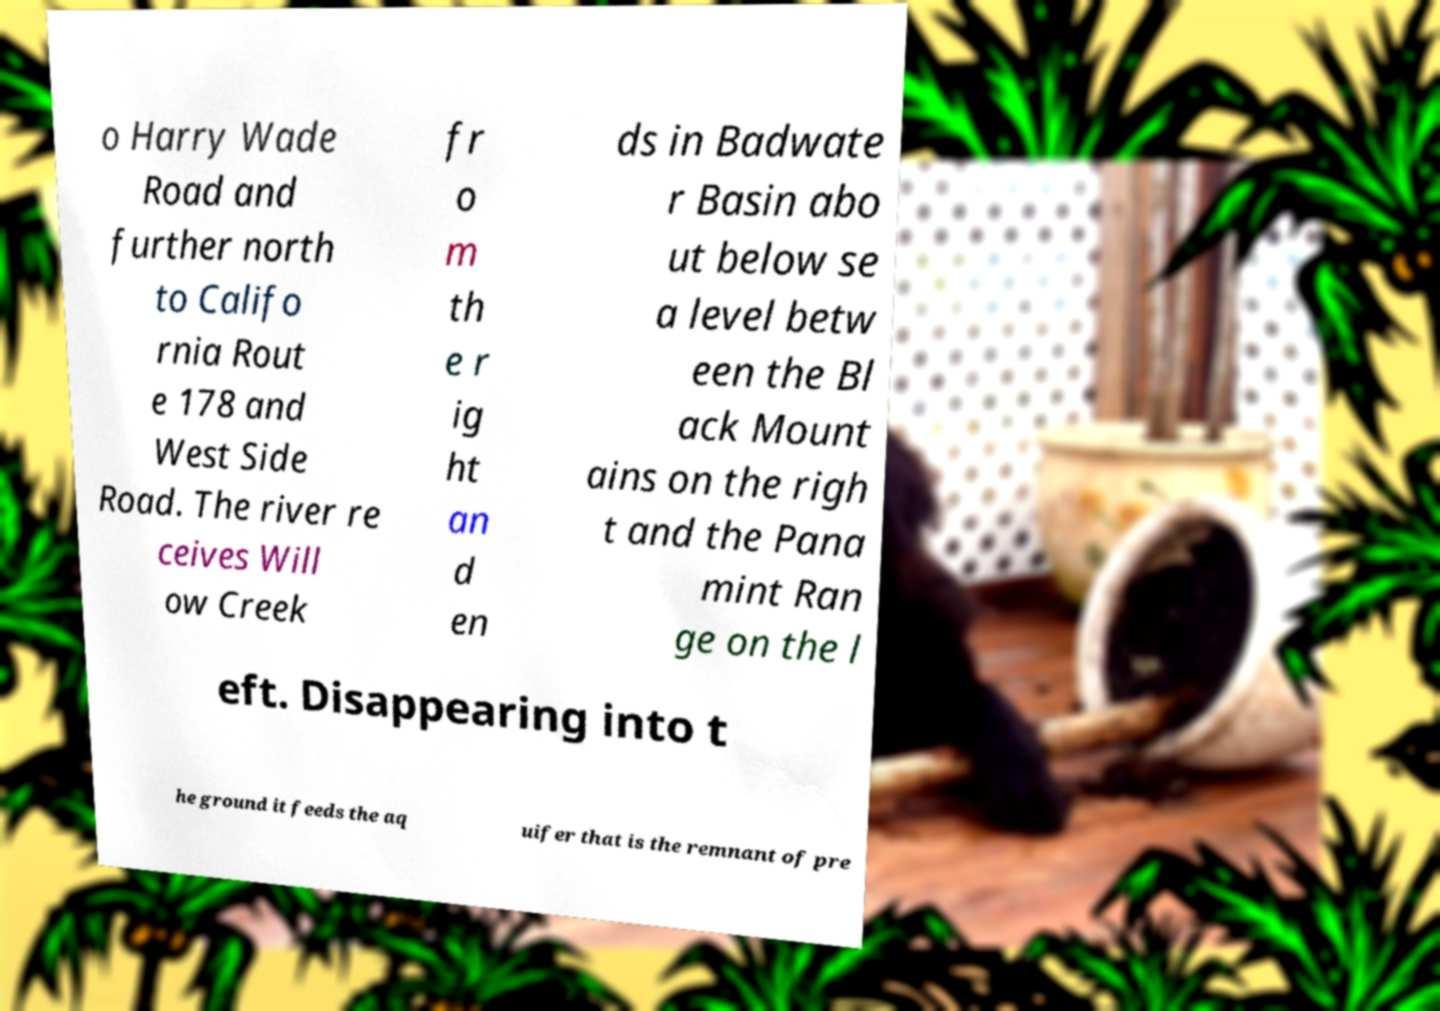I need the written content from this picture converted into text. Can you do that? o Harry Wade Road and further north to Califo rnia Rout e 178 and West Side Road. The river re ceives Will ow Creek fr o m th e r ig ht an d en ds in Badwate r Basin abo ut below se a level betw een the Bl ack Mount ains on the righ t and the Pana mint Ran ge on the l eft. Disappearing into t he ground it feeds the aq uifer that is the remnant of pre 